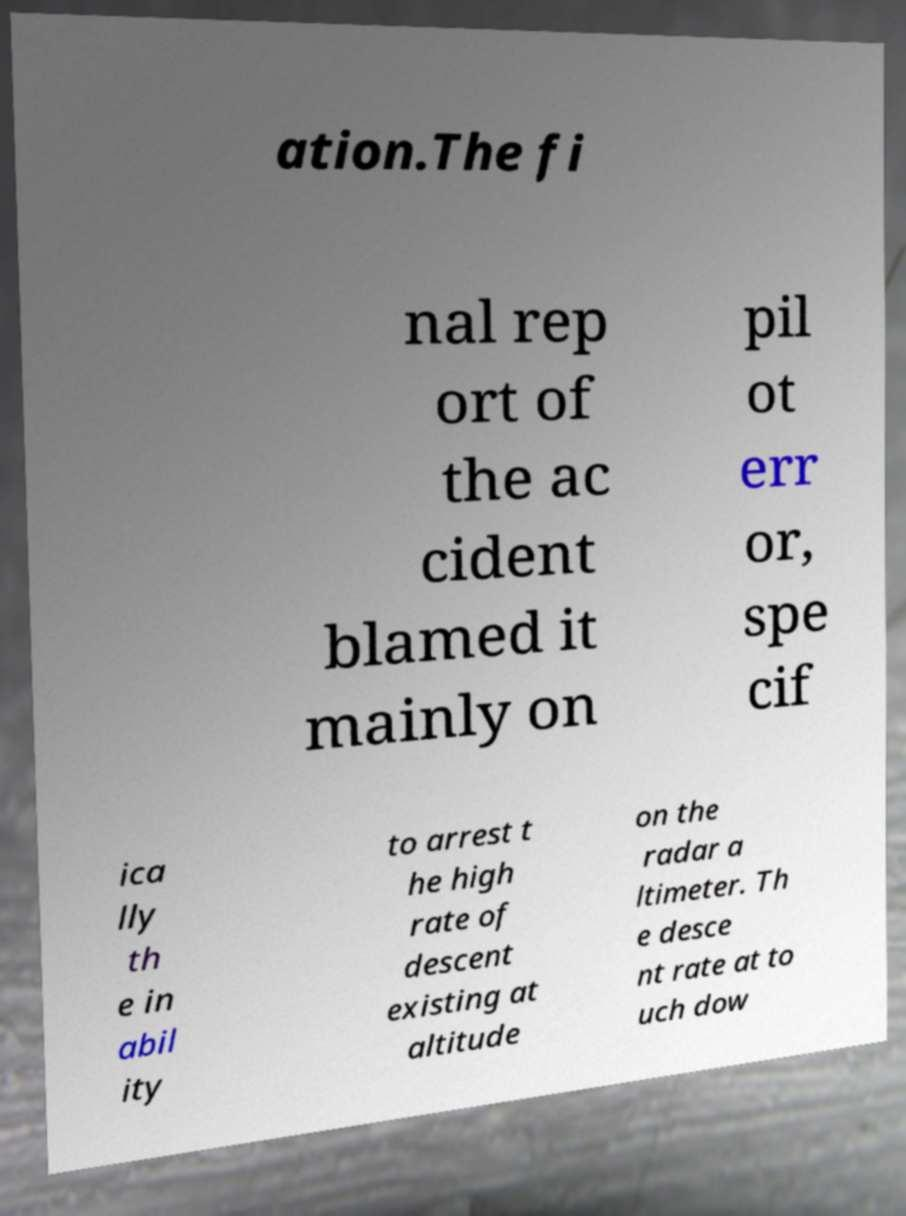Please identify and transcribe the text found in this image. ation.The fi nal rep ort of the ac cident blamed it mainly on pil ot err or, spe cif ica lly th e in abil ity to arrest t he high rate of descent existing at altitude on the radar a ltimeter. Th e desce nt rate at to uch dow 